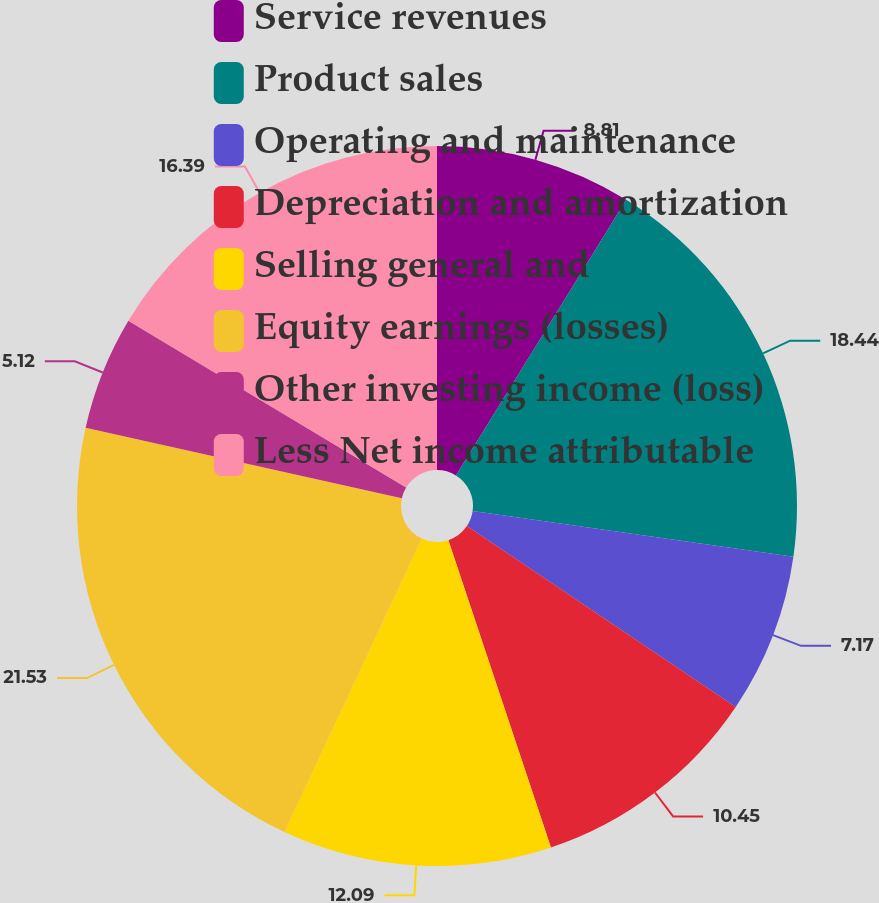Convert chart. <chart><loc_0><loc_0><loc_500><loc_500><pie_chart><fcel>Service revenues<fcel>Product sales<fcel>Operating and maintenance<fcel>Depreciation and amortization<fcel>Selling general and<fcel>Equity earnings (losses)<fcel>Other investing income (loss)<fcel>Less Net income attributable<nl><fcel>8.81%<fcel>18.44%<fcel>7.17%<fcel>10.45%<fcel>12.09%<fcel>21.52%<fcel>5.12%<fcel>16.39%<nl></chart> 